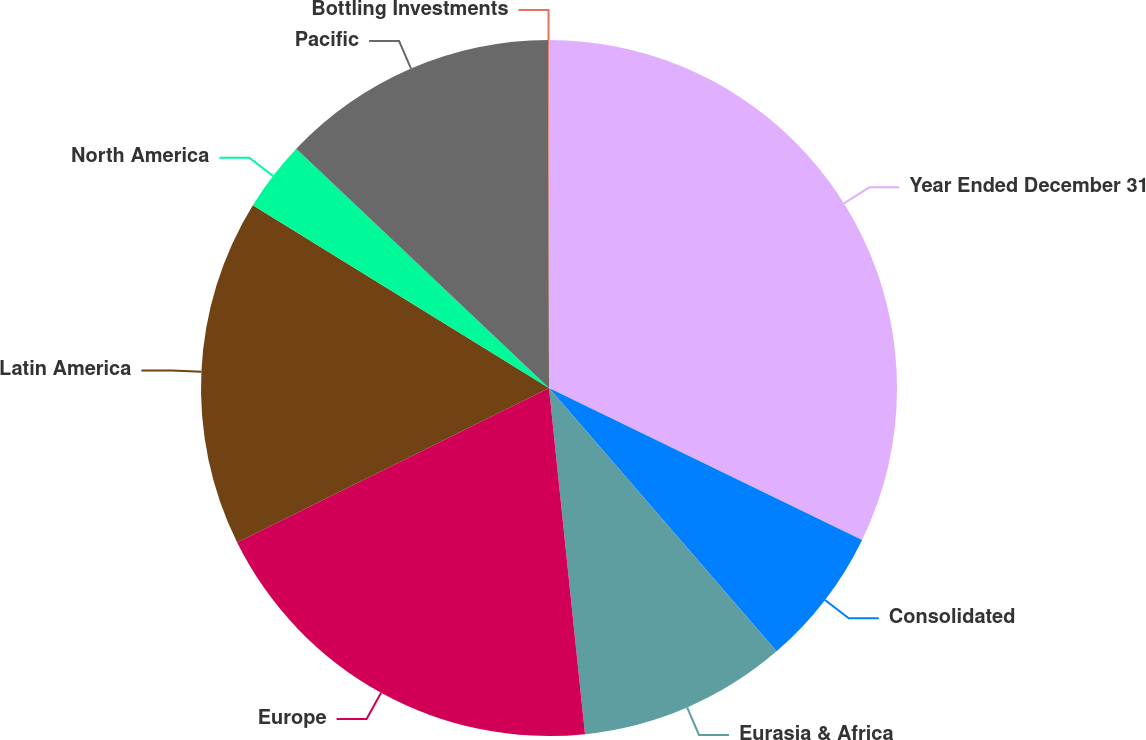Convert chart. <chart><loc_0><loc_0><loc_500><loc_500><pie_chart><fcel>Year Ended December 31<fcel>Consolidated<fcel>Eurasia & Africa<fcel>Europe<fcel>Latin America<fcel>North America<fcel>Pacific<fcel>Bottling Investments<nl><fcel>32.19%<fcel>6.47%<fcel>9.69%<fcel>19.33%<fcel>16.12%<fcel>3.26%<fcel>12.9%<fcel>0.04%<nl></chart> 